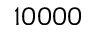<formula> <loc_0><loc_0><loc_500><loc_500>1 0 0 0 0</formula> 